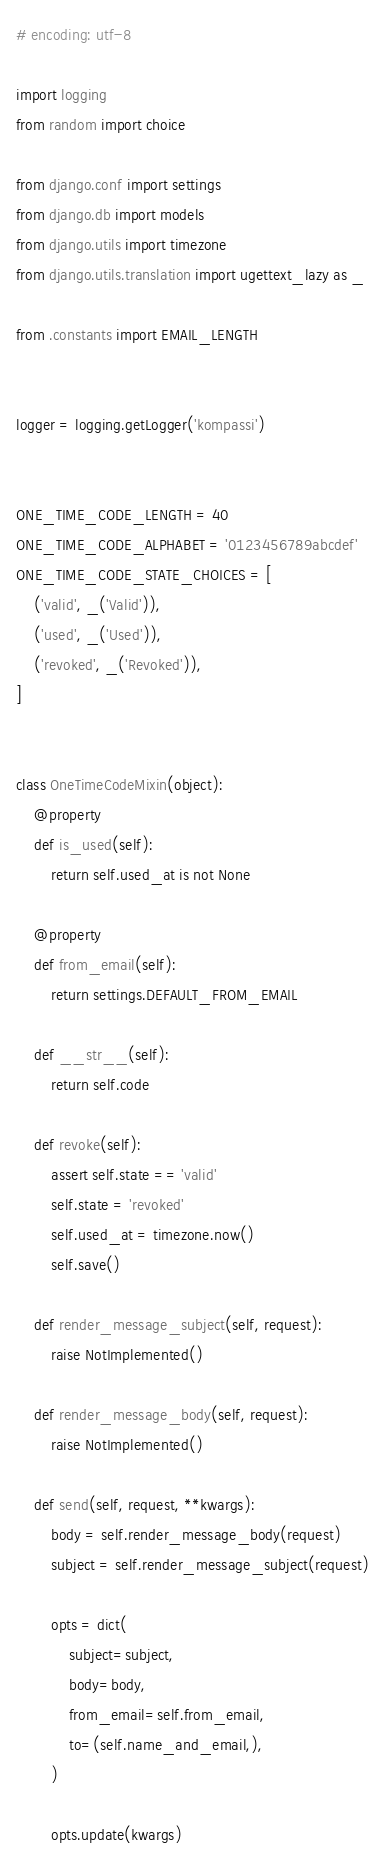<code> <loc_0><loc_0><loc_500><loc_500><_Python_># encoding: utf-8

import logging
from random import choice

from django.conf import settings
from django.db import models
from django.utils import timezone
from django.utils.translation import ugettext_lazy as _

from .constants import EMAIL_LENGTH


logger = logging.getLogger('kompassi')


ONE_TIME_CODE_LENGTH = 40
ONE_TIME_CODE_ALPHABET = '0123456789abcdef'
ONE_TIME_CODE_STATE_CHOICES = [
    ('valid', _('Valid')),
    ('used', _('Used')),
    ('revoked', _('Revoked')),
]


class OneTimeCodeMixin(object):
    @property
    def is_used(self):
        return self.used_at is not None

    @property
    def from_email(self):
        return settings.DEFAULT_FROM_EMAIL

    def __str__(self):
        return self.code

    def revoke(self):
        assert self.state == 'valid'
        self.state = 'revoked'
        self.used_at = timezone.now()
        self.save()

    def render_message_subject(self, request):
        raise NotImplemented()

    def render_message_body(self, request):
        raise NotImplemented()

    def send(self, request, **kwargs):
        body = self.render_message_body(request)
        subject = self.render_message_subject(request)

        opts = dict(
            subject=subject,
            body=body,
            from_email=self.from_email,
            to=(self.name_and_email,),
        )

        opts.update(kwargs)
</code> 